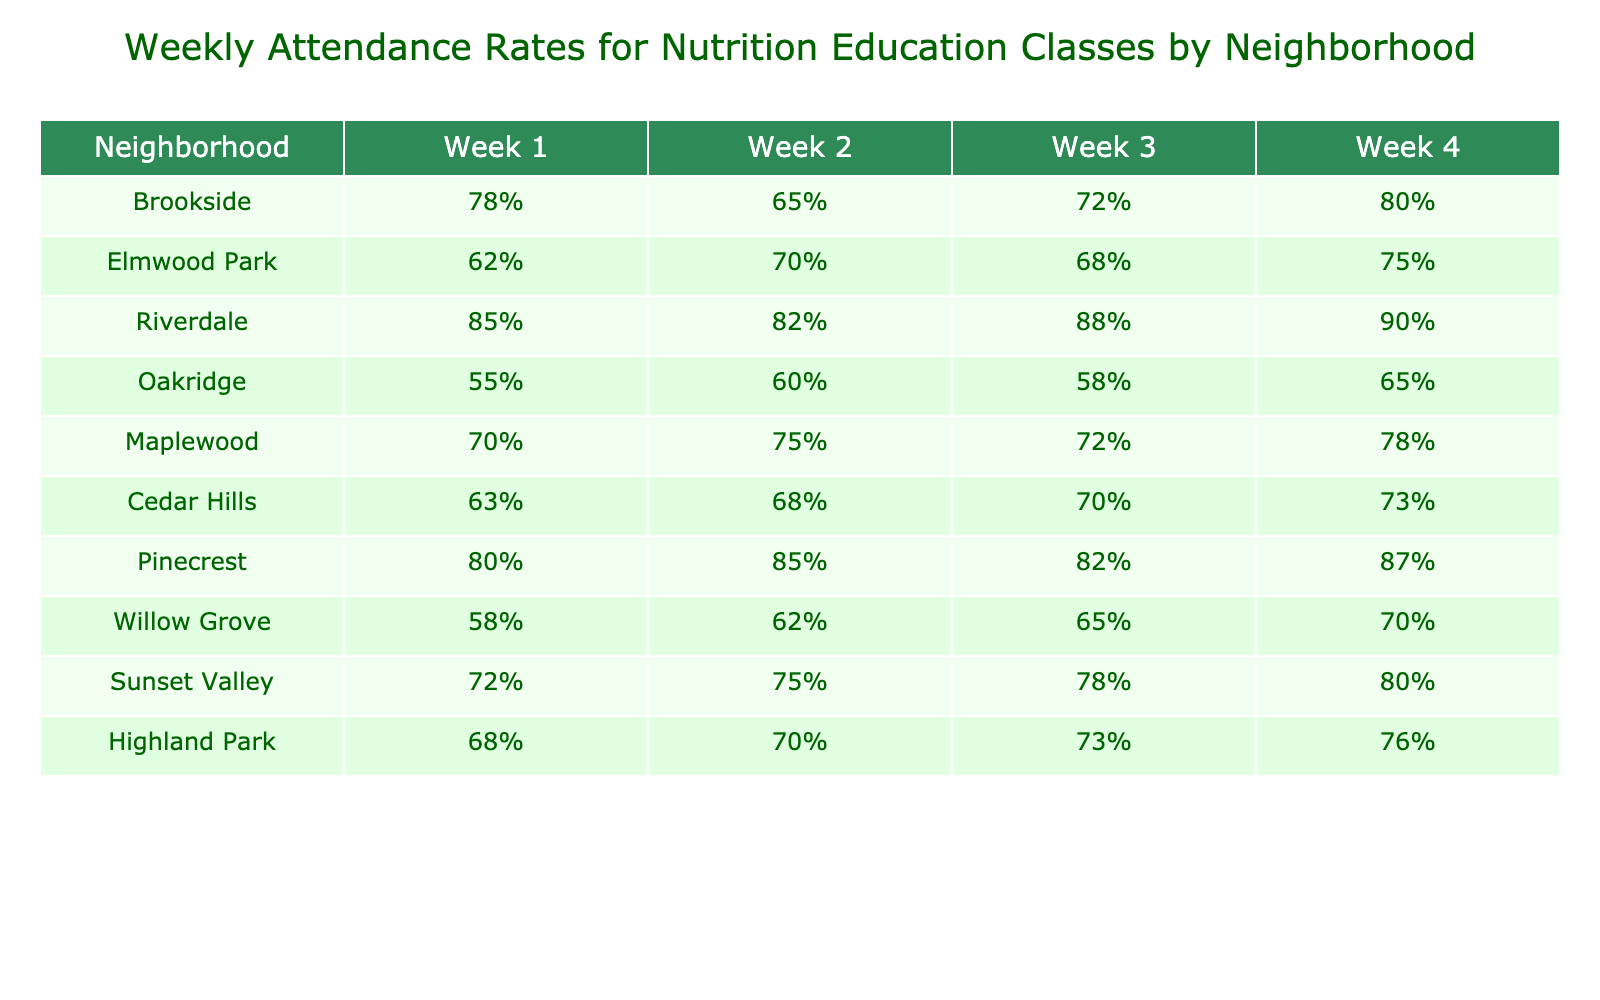What is the attendance rate for Riverdale in Week 3? From the table, we can directly refer to the row for Riverdale and find the attendance rate corresponding to Week 3, which is listed as 88%.
Answer: 88% Which neighborhood had the highest attendance rate in Week 1? Looking across the Week 1 column, Riverdale has the highest attendance rate at 85%.
Answer: Riverdale What is the average attendance rate for Pinecrest across all weeks? To find the average, we add the attendance rates for Pinecrest: (80% + 85% + 82% + 87%) = 334%. There are 4 weeks, so we divide 334% by 4, which gives us 83.5%.
Answer: 83.5% Did any neighborhood have an attendance rate below 60% in Week 2? By examining the Week 2 column, Oakridge has an attendance rate of 60%, and all other neighborhoods have higher rates, confirming that none were below 60%.
Answer: No What is the difference in attendance rate between Week 4 and Week 1 for Maplewood? For Maplewood, Week 1 is 70% and Week 4 is 78%. The difference is calculated as 78% - 70% = 8%.
Answer: 8% Which neighborhood had the lowest overall attendance throughout all weeks? We need to calculate the total attendance for each neighborhood. After summing up all weeks' attendance rates, Oakridge has the lowest total (65% + 58% + 60% + 55% = 238%).
Answer: Oakridge Was there an increase in attendance for Sunset Valley from Week 1 to Week 4? Checking the attendance rates, Week 1 for Sunset Valley is 72%, and Week 4 is 80%. There was an increase, calculated as 80% - 72% = 8%.
Answer: Yes Which neighborhood experienced the largest single-week improvement from Week 2 to Week 3? Looking at the changes between Week 2 and Week 3 for each neighborhood, Pinecrest improved from 85% to 82% (a decrease), while Riverdale improved from 82% to 88%, amounting to an increase of 6%.
Answer: Riverdale What percentage did Elmwood Park improve from Week 1 to Week 4? Elmwood Park's attendance in Week 1 is 62%, and in Week 4 it is 75%. The improvement is calculated as 75% - 62% = 13%.
Answer: 13% Which neighborhood had a consistent attendance rate in the last two weeks? Checking Week 3 and Week 4 for consistency, only Riverdale maintained an attendance of 88% and 90% respectively, showing this consistency.
Answer: No 